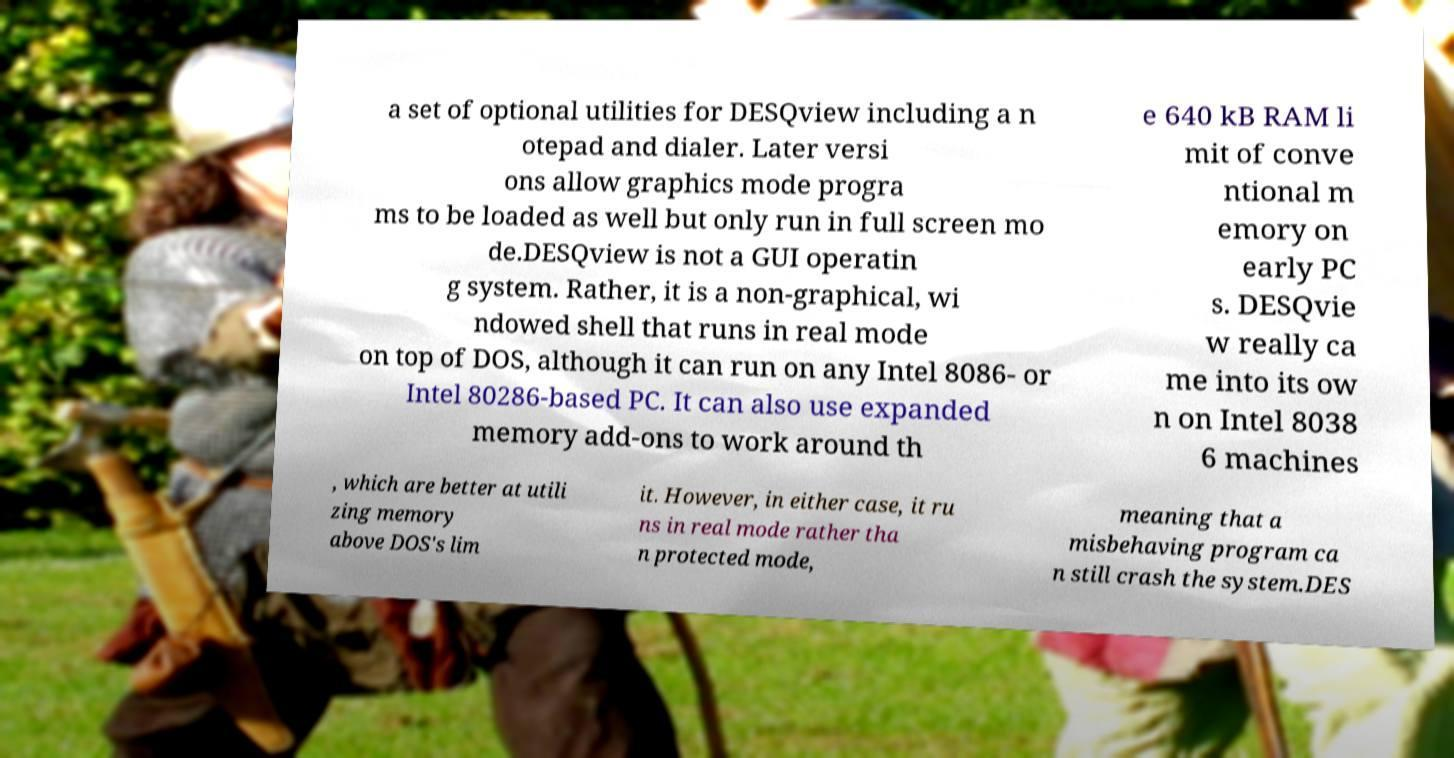Could you extract and type out the text from this image? a set of optional utilities for DESQview including a n otepad and dialer. Later versi ons allow graphics mode progra ms to be loaded as well but only run in full screen mo de.DESQview is not a GUI operatin g system. Rather, it is a non-graphical, wi ndowed shell that runs in real mode on top of DOS, although it can run on any Intel 8086- or Intel 80286-based PC. It can also use expanded memory add-ons to work around th e 640 kB RAM li mit of conve ntional m emory on early PC s. DESQvie w really ca me into its ow n on Intel 8038 6 machines , which are better at utili zing memory above DOS's lim it. However, in either case, it ru ns in real mode rather tha n protected mode, meaning that a misbehaving program ca n still crash the system.DES 